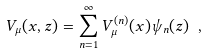Convert formula to latex. <formula><loc_0><loc_0><loc_500><loc_500>V _ { \mu } ( x , z ) = \sum ^ { \infty } _ { n = 1 } V ^ { ( n ) } _ { \mu } ( x ) \psi _ { n } ( z ) \ ,</formula> 